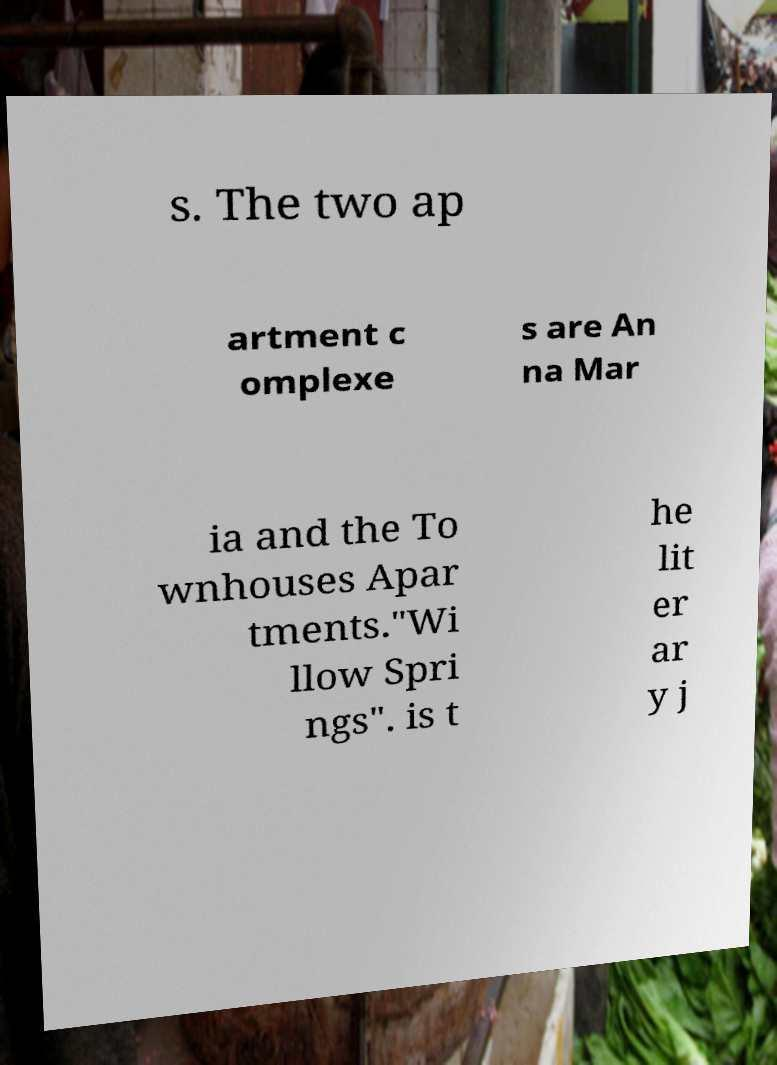Please identify and transcribe the text found in this image. s. The two ap artment c omplexe s are An na Mar ia and the To wnhouses Apar tments."Wi llow Spri ngs". is t he lit er ar y j 